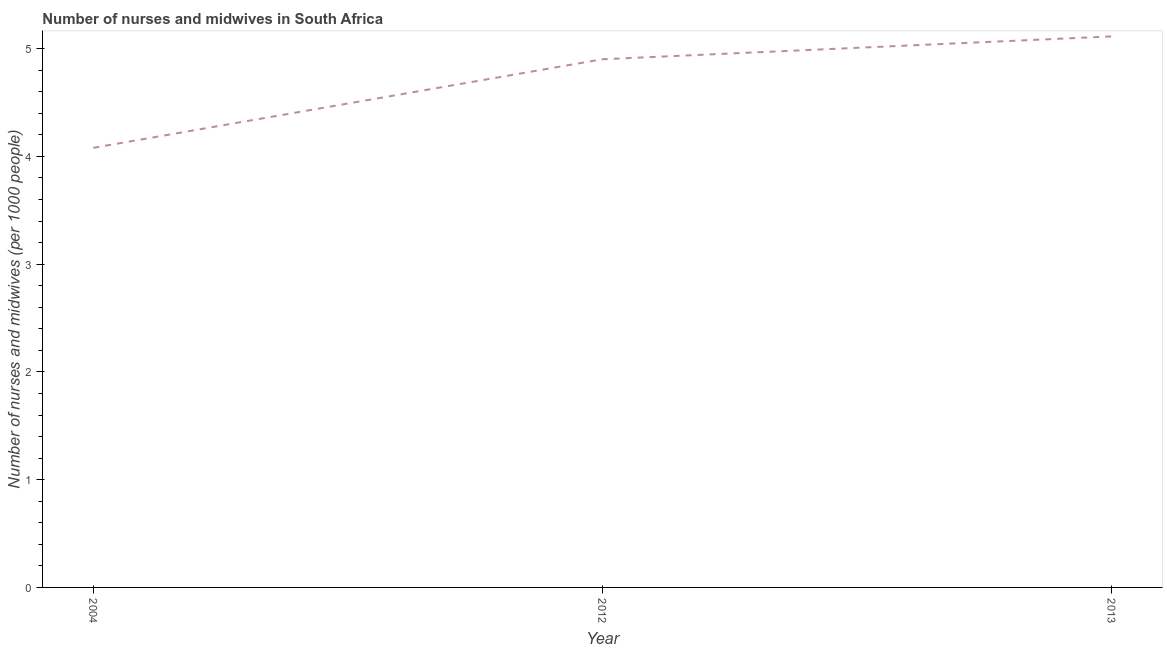What is the number of nurses and midwives in 2004?
Offer a very short reply. 4.08. Across all years, what is the maximum number of nurses and midwives?
Offer a terse response. 5.11. Across all years, what is the minimum number of nurses and midwives?
Your answer should be very brief. 4.08. In which year was the number of nurses and midwives maximum?
Give a very brief answer. 2013. In which year was the number of nurses and midwives minimum?
Your answer should be compact. 2004. What is the sum of the number of nurses and midwives?
Your answer should be very brief. 14.1. What is the difference between the number of nurses and midwives in 2004 and 2013?
Offer a very short reply. -1.03. What is the average number of nurses and midwives per year?
Ensure brevity in your answer.  4.7. What is the median number of nurses and midwives?
Give a very brief answer. 4.9. In how many years, is the number of nurses and midwives greater than 0.6000000000000001 ?
Offer a terse response. 3. Do a majority of the years between 2013 and 2004 (inclusive) have number of nurses and midwives greater than 1.8 ?
Offer a terse response. No. What is the ratio of the number of nurses and midwives in 2004 to that in 2013?
Your answer should be very brief. 0.8. Is the difference between the number of nurses and midwives in 2012 and 2013 greater than the difference between any two years?
Offer a terse response. No. What is the difference between the highest and the second highest number of nurses and midwives?
Keep it short and to the point. 0.21. Is the sum of the number of nurses and midwives in 2012 and 2013 greater than the maximum number of nurses and midwives across all years?
Give a very brief answer. Yes. What is the difference between the highest and the lowest number of nurses and midwives?
Offer a terse response. 1.03. In how many years, is the number of nurses and midwives greater than the average number of nurses and midwives taken over all years?
Give a very brief answer. 2. Does the number of nurses and midwives monotonically increase over the years?
Give a very brief answer. Yes. Are the values on the major ticks of Y-axis written in scientific E-notation?
Your answer should be compact. No. Does the graph contain any zero values?
Provide a succinct answer. No. Does the graph contain grids?
Your answer should be very brief. No. What is the title of the graph?
Ensure brevity in your answer.  Number of nurses and midwives in South Africa. What is the label or title of the Y-axis?
Make the answer very short. Number of nurses and midwives (per 1000 people). What is the Number of nurses and midwives (per 1000 people) of 2004?
Give a very brief answer. 4.08. What is the Number of nurses and midwives (per 1000 people) in 2012?
Your answer should be compact. 4.9. What is the Number of nurses and midwives (per 1000 people) of 2013?
Your answer should be very brief. 5.11. What is the difference between the Number of nurses and midwives (per 1000 people) in 2004 and 2012?
Keep it short and to the point. -0.82. What is the difference between the Number of nurses and midwives (per 1000 people) in 2004 and 2013?
Give a very brief answer. -1.03. What is the difference between the Number of nurses and midwives (per 1000 people) in 2012 and 2013?
Offer a terse response. -0.21. What is the ratio of the Number of nurses and midwives (per 1000 people) in 2004 to that in 2012?
Give a very brief answer. 0.83. What is the ratio of the Number of nurses and midwives (per 1000 people) in 2004 to that in 2013?
Make the answer very short. 0.8. 